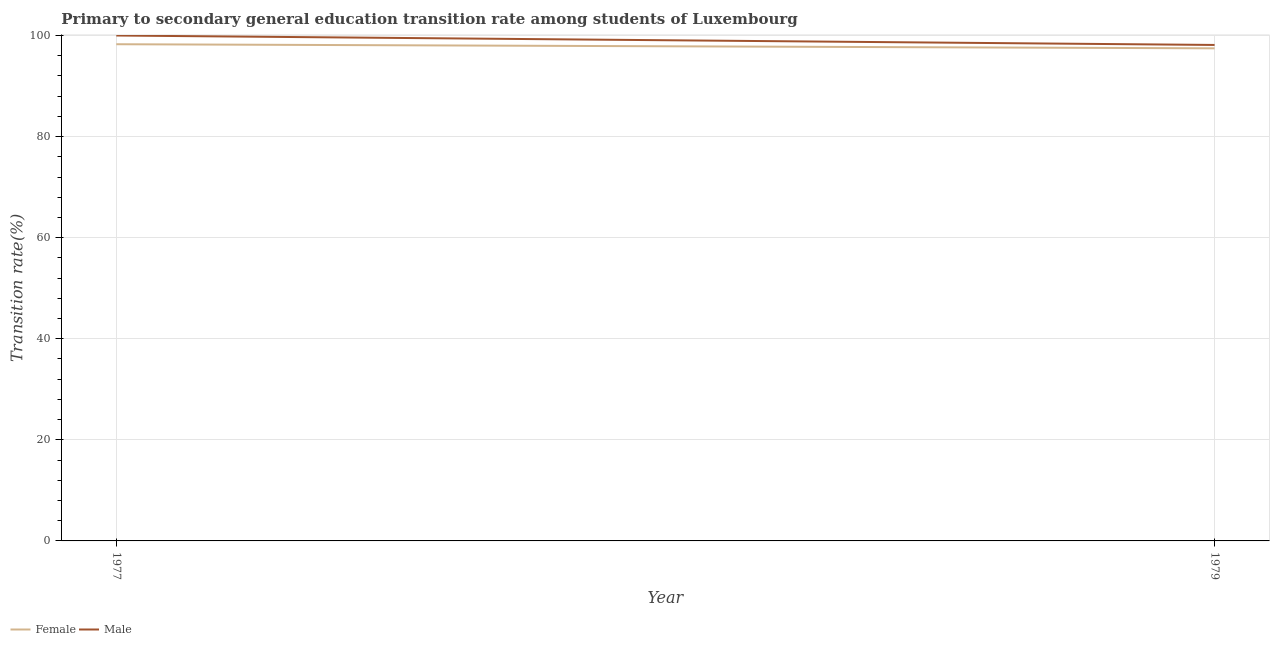How many different coloured lines are there?
Offer a terse response. 2. Does the line corresponding to transition rate among female students intersect with the line corresponding to transition rate among male students?
Offer a terse response. No. What is the transition rate among female students in 1979?
Your answer should be very brief. 97.46. Across all years, what is the minimum transition rate among male students?
Your response must be concise. 98.13. In which year was the transition rate among female students maximum?
Give a very brief answer. 1977. In which year was the transition rate among female students minimum?
Your answer should be compact. 1979. What is the total transition rate among male students in the graph?
Keep it short and to the point. 198.13. What is the difference between the transition rate among female students in 1977 and that in 1979?
Your answer should be compact. 0.81. What is the difference between the transition rate among male students in 1979 and the transition rate among female students in 1977?
Provide a short and direct response. -0.15. What is the average transition rate among male students per year?
Keep it short and to the point. 99.07. In the year 1979, what is the difference between the transition rate among female students and transition rate among male students?
Your answer should be compact. -0.67. In how many years, is the transition rate among female students greater than 48 %?
Offer a very short reply. 2. What is the ratio of the transition rate among female students in 1977 to that in 1979?
Your response must be concise. 1.01. Is the transition rate among male students in 1977 less than that in 1979?
Your answer should be very brief. No. In how many years, is the transition rate among male students greater than the average transition rate among male students taken over all years?
Your answer should be compact. 1. How many lines are there?
Offer a very short reply. 2. What is the difference between two consecutive major ticks on the Y-axis?
Offer a terse response. 20. What is the title of the graph?
Provide a succinct answer. Primary to secondary general education transition rate among students of Luxembourg. Does "Female labourers" appear as one of the legend labels in the graph?
Your answer should be very brief. No. What is the label or title of the Y-axis?
Provide a succinct answer. Transition rate(%). What is the Transition rate(%) in Female in 1977?
Make the answer very short. 98.28. What is the Transition rate(%) in Female in 1979?
Provide a succinct answer. 97.46. What is the Transition rate(%) in Male in 1979?
Your answer should be very brief. 98.13. Across all years, what is the maximum Transition rate(%) of Female?
Offer a very short reply. 98.28. Across all years, what is the minimum Transition rate(%) in Female?
Provide a succinct answer. 97.46. Across all years, what is the minimum Transition rate(%) of Male?
Your response must be concise. 98.13. What is the total Transition rate(%) of Female in the graph?
Make the answer very short. 195.74. What is the total Transition rate(%) of Male in the graph?
Offer a very short reply. 198.13. What is the difference between the Transition rate(%) in Female in 1977 and that in 1979?
Give a very brief answer. 0.81. What is the difference between the Transition rate(%) of Male in 1977 and that in 1979?
Your response must be concise. 1.87. What is the difference between the Transition rate(%) in Female in 1977 and the Transition rate(%) in Male in 1979?
Your answer should be compact. 0.15. What is the average Transition rate(%) in Female per year?
Offer a very short reply. 97.87. What is the average Transition rate(%) of Male per year?
Your response must be concise. 99.07. In the year 1977, what is the difference between the Transition rate(%) of Female and Transition rate(%) of Male?
Your response must be concise. -1.72. In the year 1979, what is the difference between the Transition rate(%) in Female and Transition rate(%) in Male?
Offer a very short reply. -0.67. What is the ratio of the Transition rate(%) of Female in 1977 to that in 1979?
Ensure brevity in your answer.  1.01. What is the ratio of the Transition rate(%) in Male in 1977 to that in 1979?
Your answer should be compact. 1.02. What is the difference between the highest and the second highest Transition rate(%) in Female?
Ensure brevity in your answer.  0.81. What is the difference between the highest and the second highest Transition rate(%) of Male?
Offer a very short reply. 1.87. What is the difference between the highest and the lowest Transition rate(%) in Female?
Keep it short and to the point. 0.81. What is the difference between the highest and the lowest Transition rate(%) of Male?
Make the answer very short. 1.87. 